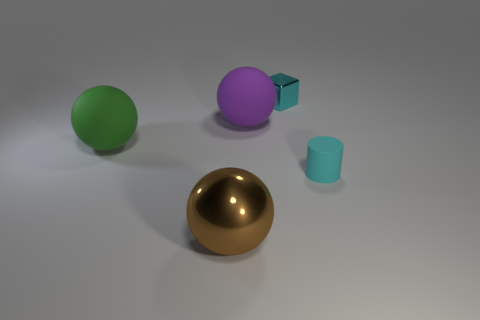Subtract all brown metal balls. How many balls are left? 2 Subtract all green spheres. How many spheres are left? 2 Subtract all blocks. How many objects are left? 4 Subtract all blue cubes. How many gray balls are left? 0 Add 4 brown objects. How many objects exist? 9 Subtract all green cubes. Subtract all gray balls. How many cubes are left? 1 Subtract all large gray rubber cubes. Subtract all brown metal objects. How many objects are left? 4 Add 3 tiny objects. How many tiny objects are left? 5 Add 3 big purple things. How many big purple things exist? 4 Subtract 0 purple cylinders. How many objects are left? 5 